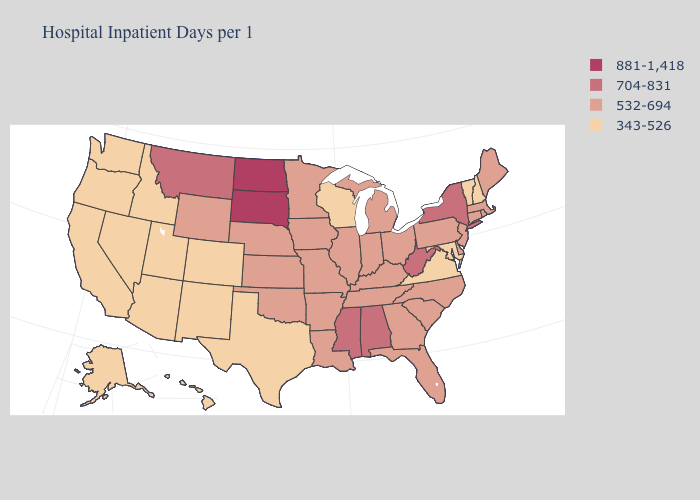Does the first symbol in the legend represent the smallest category?
Write a very short answer. No. Name the states that have a value in the range 704-831?
Keep it brief. Alabama, Mississippi, Montana, New York, West Virginia. Which states have the highest value in the USA?
Be succinct. North Dakota, South Dakota. What is the lowest value in states that border Mississippi?
Quick response, please. 532-694. Name the states that have a value in the range 343-526?
Keep it brief. Alaska, Arizona, California, Colorado, Hawaii, Idaho, Maryland, Nevada, New Hampshire, New Mexico, Oregon, Texas, Utah, Vermont, Virginia, Washington, Wisconsin. What is the value of Kentucky?
Concise answer only. 532-694. What is the highest value in states that border Iowa?
Give a very brief answer. 881-1,418. Name the states that have a value in the range 704-831?
Keep it brief. Alabama, Mississippi, Montana, New York, West Virginia. Does Minnesota have the lowest value in the USA?
Be succinct. No. Name the states that have a value in the range 704-831?
Keep it brief. Alabama, Mississippi, Montana, New York, West Virginia. Does Massachusetts have a lower value than Mississippi?
Give a very brief answer. Yes. Which states have the lowest value in the USA?
Write a very short answer. Alaska, Arizona, California, Colorado, Hawaii, Idaho, Maryland, Nevada, New Hampshire, New Mexico, Oregon, Texas, Utah, Vermont, Virginia, Washington, Wisconsin. What is the highest value in the South ?
Concise answer only. 704-831. What is the highest value in the Northeast ?
Answer briefly. 704-831. Name the states that have a value in the range 532-694?
Quick response, please. Arkansas, Connecticut, Delaware, Florida, Georgia, Illinois, Indiana, Iowa, Kansas, Kentucky, Louisiana, Maine, Massachusetts, Michigan, Minnesota, Missouri, Nebraska, New Jersey, North Carolina, Ohio, Oklahoma, Pennsylvania, Rhode Island, South Carolina, Tennessee, Wyoming. 